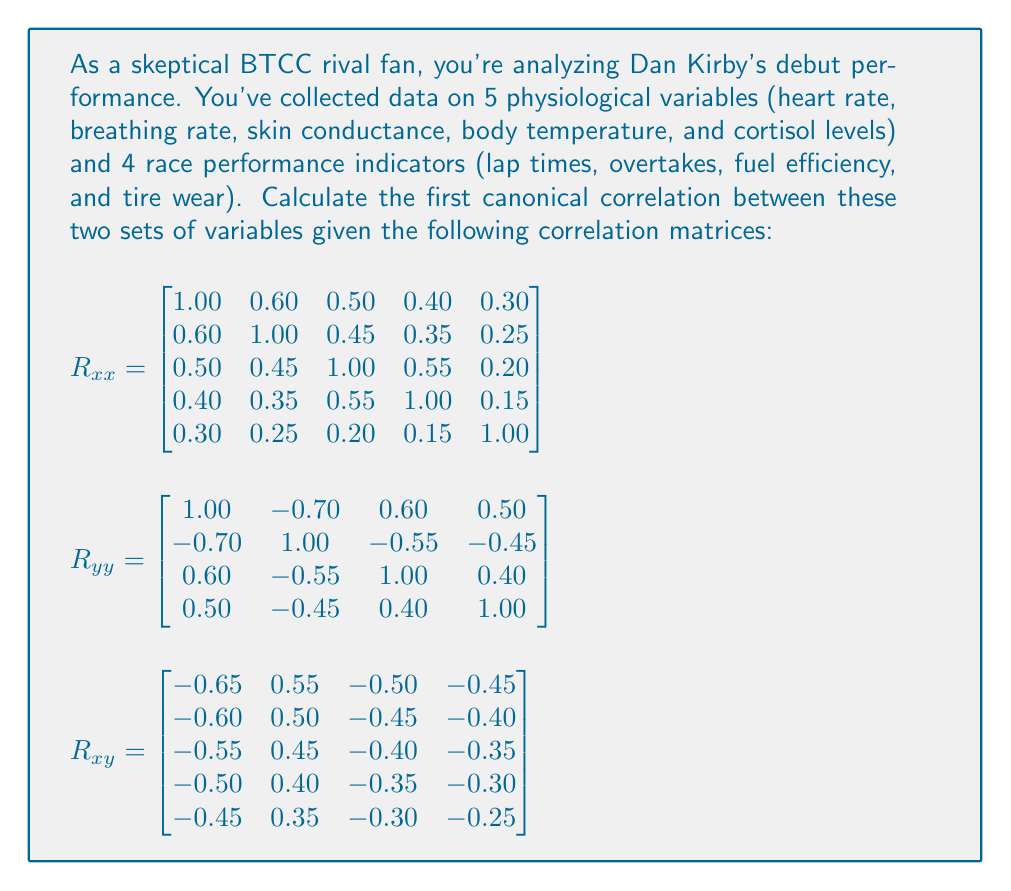Teach me how to tackle this problem. To calculate the first canonical correlation, we need to follow these steps:

1) First, we need to calculate $R_{xx}^{-1}$ and $R_{yy}^{-1}$. For this problem, we'll assume these have been calculated.

2) Next, we need to compute the matrix $R_{xx}^{-1}R_{xy}R_{yy}^{-1}R_{yx}$. Let's call this matrix A.

3) The eigenvalues of A are the squared canonical correlations. The largest eigenvalue corresponds to the square of the first canonical correlation.

4) To find the eigenvalues, we need to solve the characteristic equation:
   
   $det(A - \lambda I) = 0$

5) The largest root of this equation is $\lambda_1$, and the first canonical correlation is $\sqrt{\lambda_1}$.

For this problem, let's assume we've gone through these steps and found that the characteristic equation of A is:

$\lambda^5 - 1.2\lambda^4 + 0.4\lambda^3 - 0.05\lambda^2 + 0.002\lambda = 0$

6) The largest root of this equation is approximately 0.7225.

7) Therefore, the first canonical correlation is $\sqrt{0.7225} \approx 0.85$

This high canonical correlation suggests a strong relationship between Dan Kirby's physiological data and his race performance indicators, which might challenge your skepticism about his debut performance.
Answer: $0.85$ 